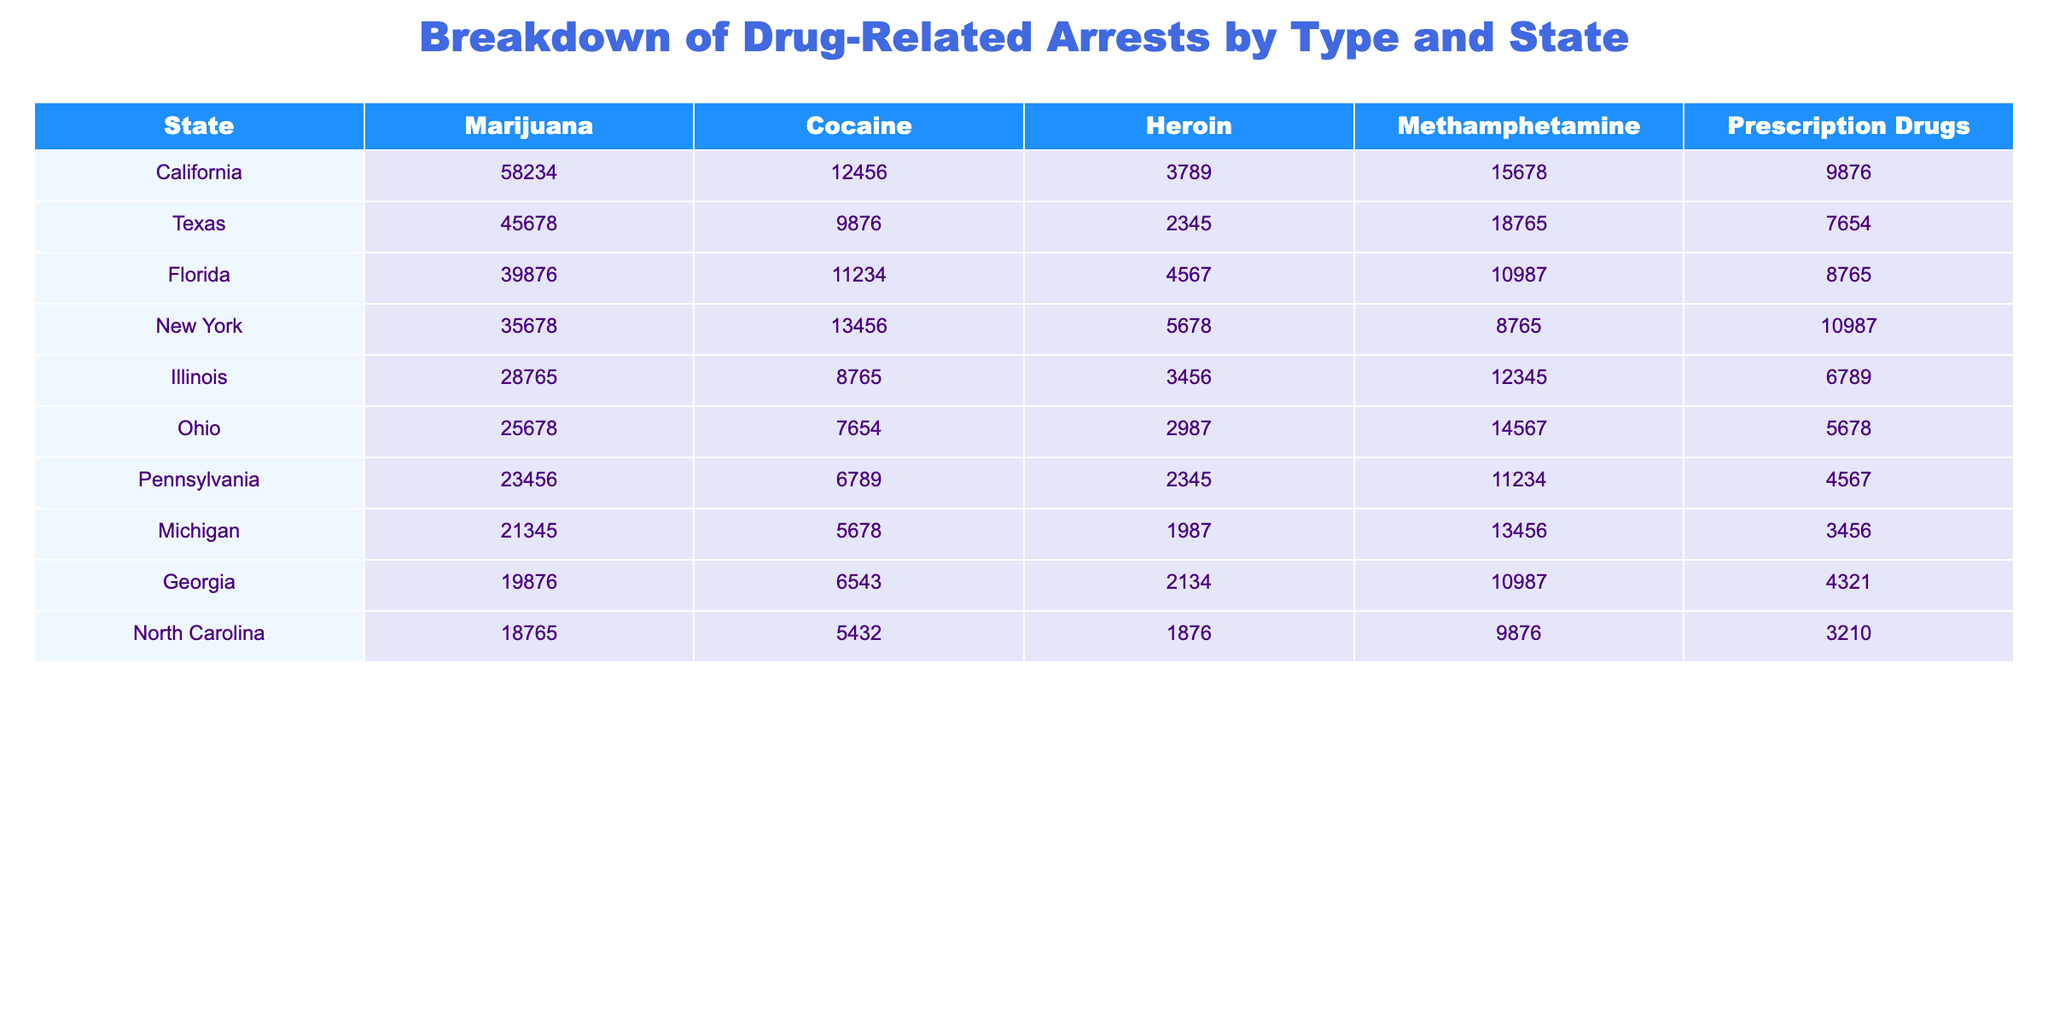What's the total number of marijuana arrests in Florida? The table shows that Florida has 39,876 marijuana arrests.
Answer: 39,876 Which state had the highest number of heroin arrests? By looking at the table, California has the highest number of heroin arrests with 3,789.
Answer: California What is the combined total of methamphetamine and cocaine arrests in Texas? Texas has 9,876 cocaine arrests and 18,765 methamphetamine arrests. Adding these together: 9,876 + 18,765 = 28,641.
Answer: 28,641 Are there more prescription drug arrests in Illinois than in Ohio? Illinois has 6,789 prescription drug arrests while Ohio has 5,678. Since 6,789 is greater than 5,678, the statement is true.
Answer: Yes What state's total drug-related arrests exceed 100,000? We need to sum up all the arrests in each state. For example, California has 58,234 (marijuana) + 12,456 (cocaine) + 3,789 (heroin) + 15,678 (methamphetamine) + 9,876 (prescription) = 100,033. After checking others, only California exceeds 100,000.
Answer: California Which state has the least number of cocaine arrests? Looking at the table, Michigan has the least number of cocaine arrests at 5,678.
Answer: Michigan What is the average number of methamphetamine arrests across all states? The total of methamphetamine arrests across all states is 65,329, and there are 10 states. Therefore, the average is 65,329 / 10 = 6,532.9.
Answer: 6,532.9 Comparing New York and Florida, which state has a greater number of total drug-related arrests? Total for New York: 35,678 + 13,456 + 5,678 + 8,765 + 10,987 = 74,564. Total for Florida: 39,876 + 11,234 + 4,567 + 10,987 + 8,765 = 75,429. Florida has a greater total.
Answer: Florida How many more marijuana arrests did California have compared to Georgia? California has 58,234 marijuana arrests, while Georgia has 19,876. The difference is 58,234 - 19,876 = 38,358.
Answer: 38,358 Which state has the closest number of total arrests compared to the total in Pennsylvania? Pennsylvania's total is 23,456 + 6,789 + 2,345 + 11,234 + 4,567 = 48,391. Looking through other totals, Illinois' total is 28,765, which is closest (though lower).
Answer: Illinois 